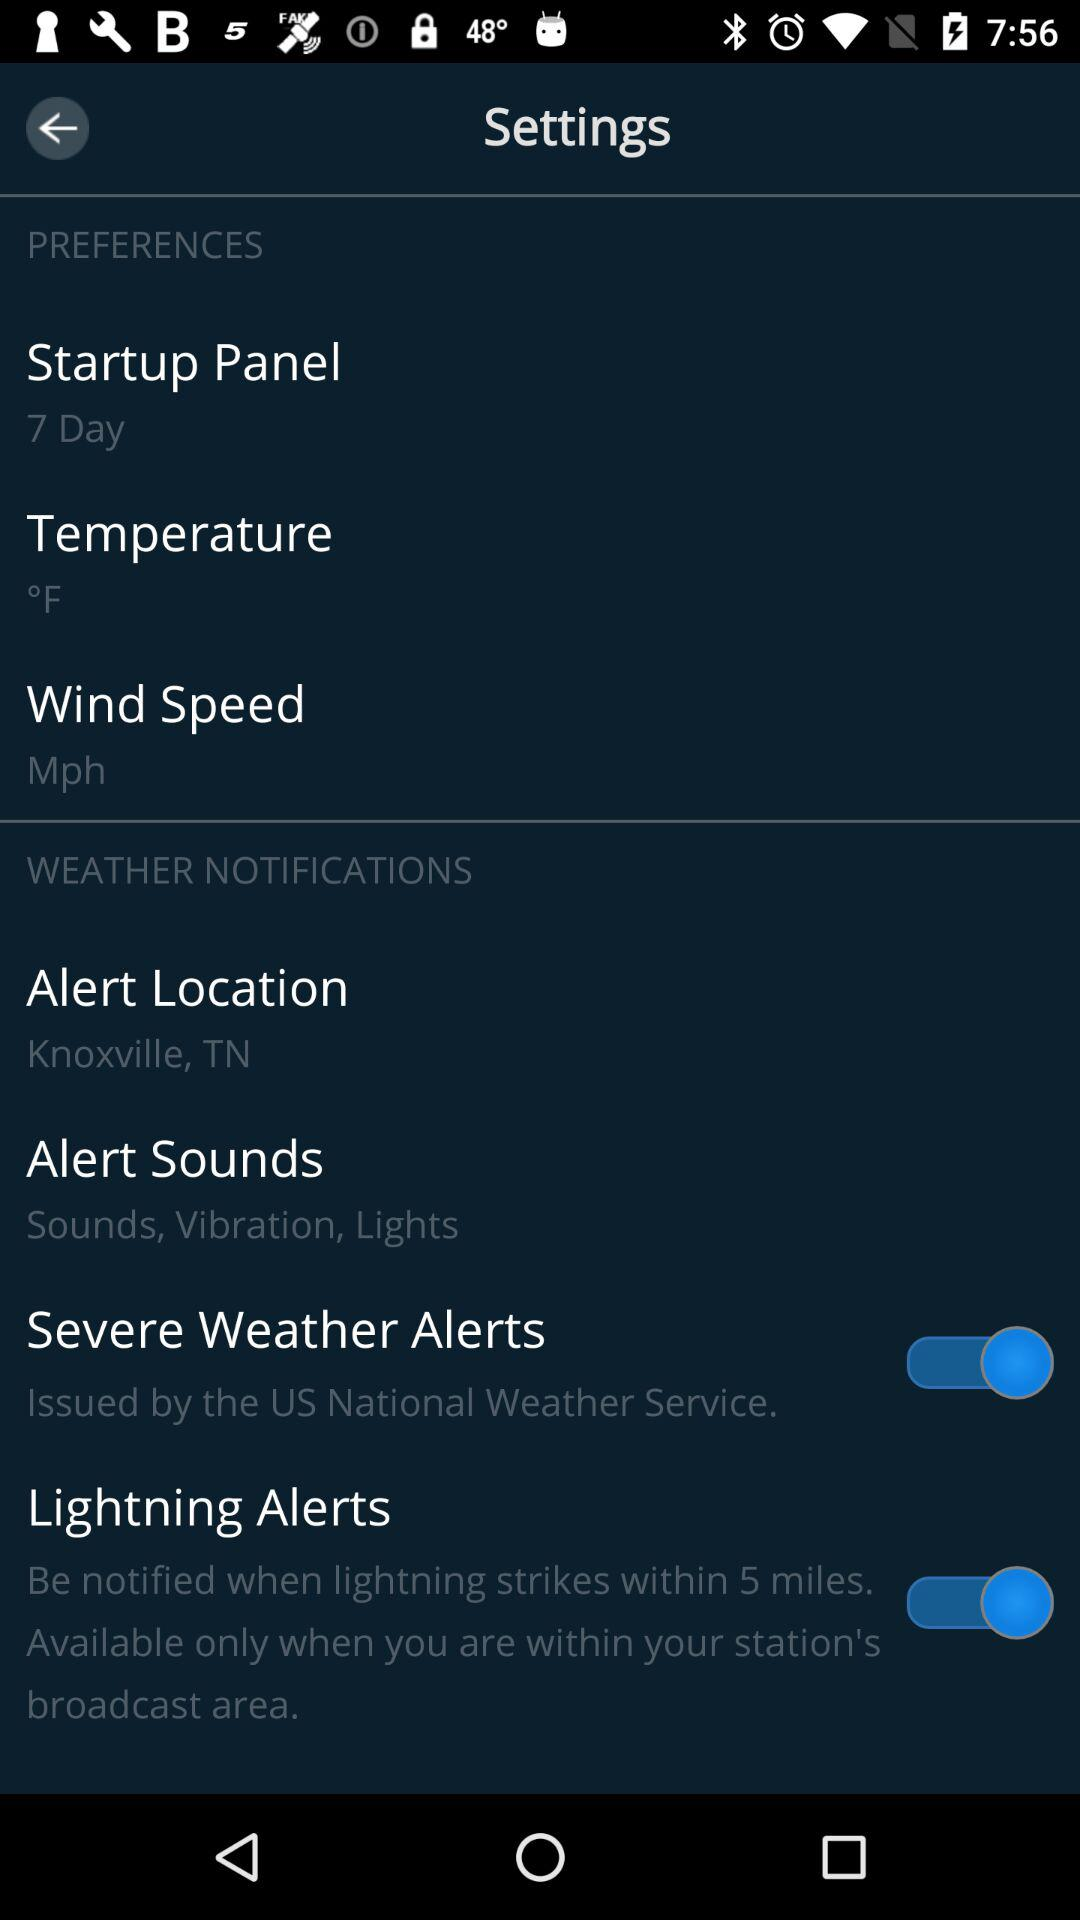What is the status of the "Lightning Alerts"? The status is "on". 